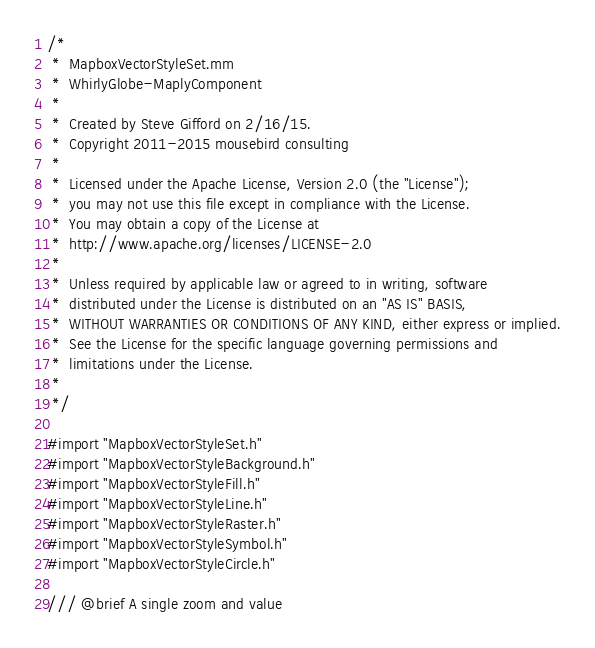Convert code to text. <code><loc_0><loc_0><loc_500><loc_500><_ObjectiveC_>/*
 *  MapboxVectorStyleSet.mm
 *  WhirlyGlobe-MaplyComponent
 *
 *  Created by Steve Gifford on 2/16/15.
 *  Copyright 2011-2015 mousebird consulting
 *
 *  Licensed under the Apache License, Version 2.0 (the "License");
 *  you may not use this file except in compliance with the License.
 *  You may obtain a copy of the License at
 *  http://www.apache.org/licenses/LICENSE-2.0
 *
 *  Unless required by applicable law or agreed to in writing, software
 *  distributed under the License is distributed on an "AS IS" BASIS,
 *  WITHOUT WARRANTIES OR CONDITIONS OF ANY KIND, either express or implied.
 *  See the License for the specific language governing permissions and
 *  limitations under the License.
 *
 */

#import "MapboxVectorStyleSet.h"
#import "MapboxVectorStyleBackground.h"
#import "MapboxVectorStyleFill.h"
#import "MapboxVectorStyleLine.h"
#import "MapboxVectorStyleRaster.h"
#import "MapboxVectorStyleSymbol.h"
#import "MapboxVectorStyleCircle.h"

/// @brief A single zoom and value</code> 